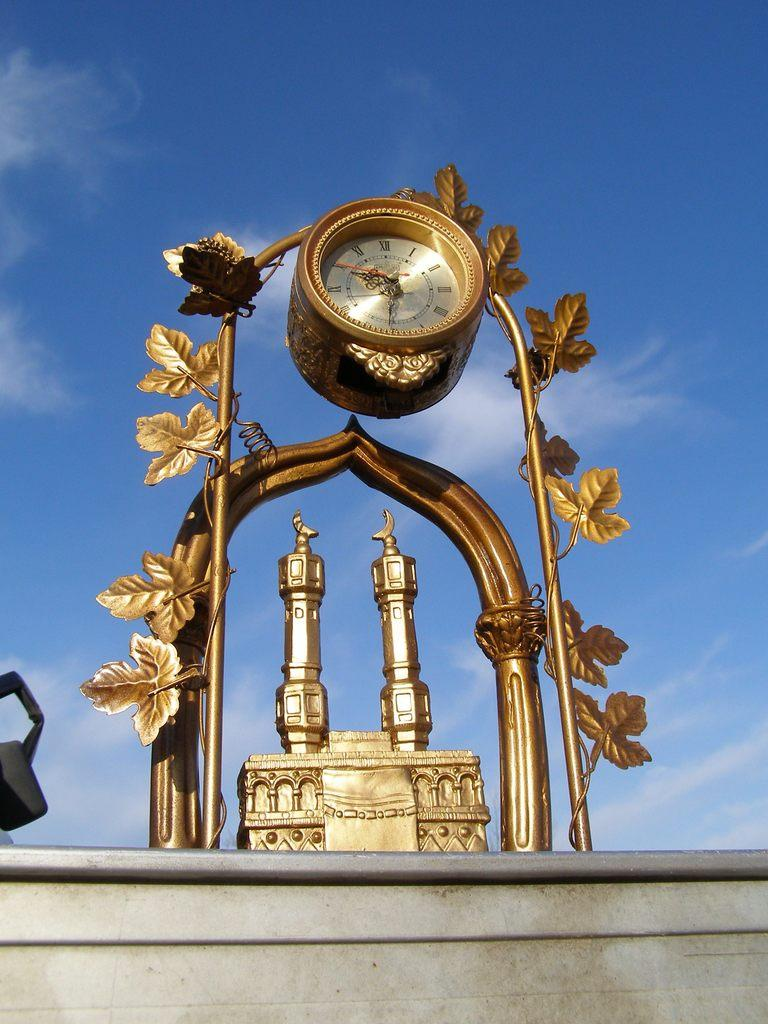<image>
Render a clear and concise summary of the photo. A golden ornate clock shows the time is 6:50. 